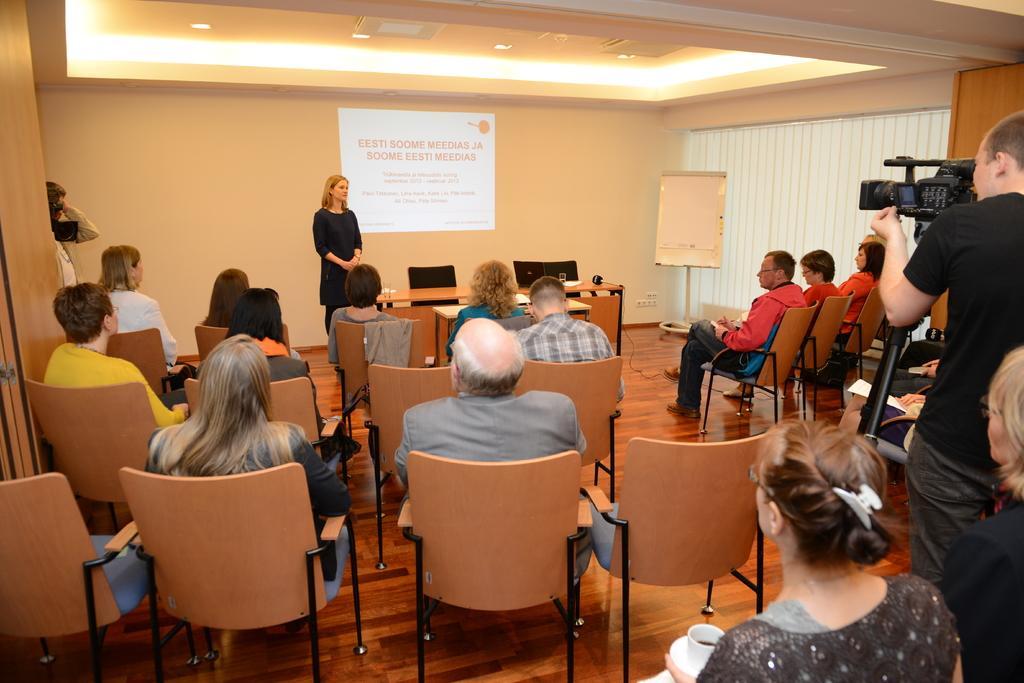Please provide a concise description of this image. In this image i can see few people sitting on chairs, a woman standing and a person standing and holding a camera. In the background i can see a wall, a board, window blind and some projection on the screen. 